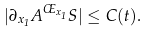Convert formula to latex. <formula><loc_0><loc_0><loc_500><loc_500>| \partial _ { x _ { 1 } } A ^ { \phi _ { x _ { 1 } } } S | \leq C ( t ) .</formula> 